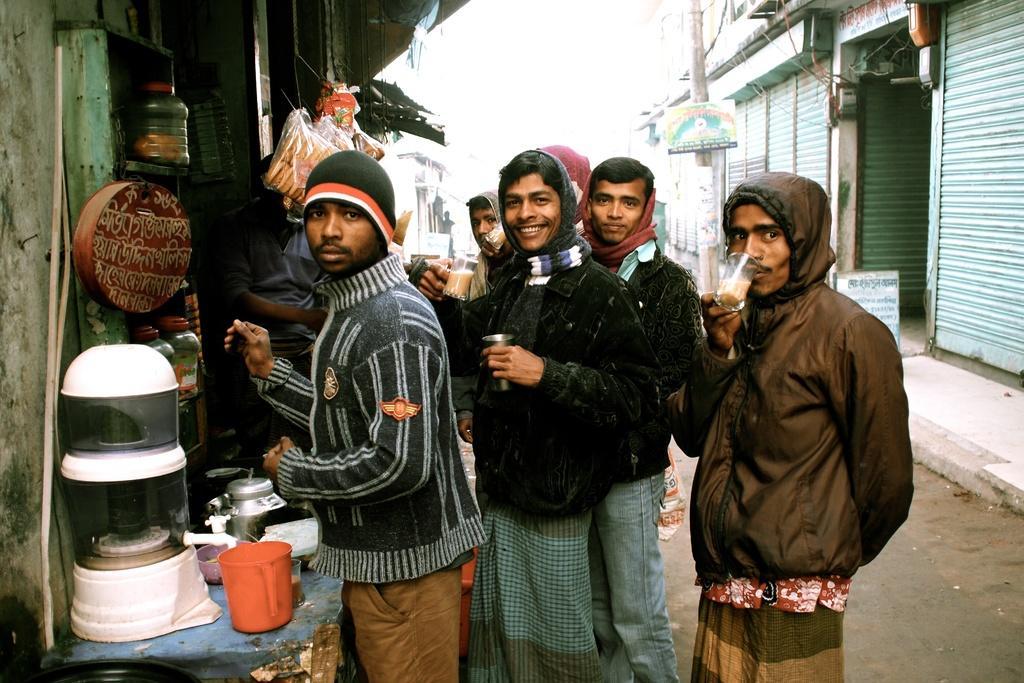Please provide a concise description of this image. This image is clicked on the road. There are many people standing and holding glasses in their hands. To the left there is a table. There are mugs, jars and glasses on the table. On the either sides of the road there are shops. At the top there is the sky. 